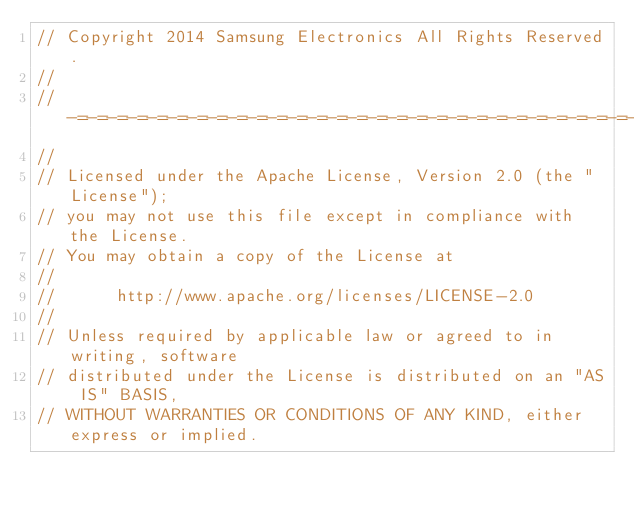<code> <loc_0><loc_0><loc_500><loc_500><_C_>// Copyright 2014 Samsung Electronics All Rights Reserved.
//
//-=-=-=-=-=-=-=-=-=-=-=-=-=-=-=-=-=-=-=-=-=-=-=-=-=-=-=-=-=-=-=-=
//
// Licensed under the Apache License, Version 2.0 (the "License");
// you may not use this file except in compliance with the License.
// You may obtain a copy of the License at
//
//      http://www.apache.org/licenses/LICENSE-2.0
//
// Unless required by applicable law or agreed to in writing, software
// distributed under the License is distributed on an "AS IS" BASIS,
// WITHOUT WARRANTIES OR CONDITIONS OF ANY KIND, either express or implied.</code> 